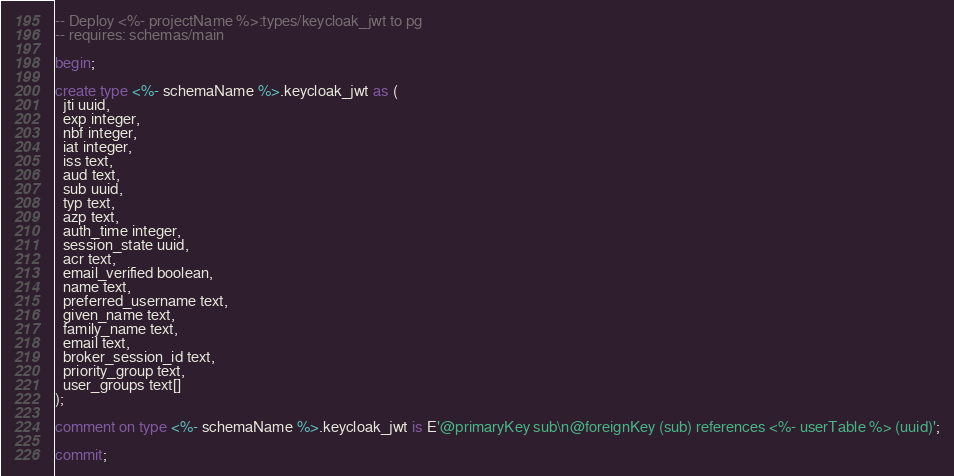Convert code to text. <code><loc_0><loc_0><loc_500><loc_500><_SQL_>-- Deploy <%- projectName %>:types/keycloak_jwt to pg
-- requires: schemas/main

begin;

create type <%- schemaName %>.keycloak_jwt as (
  jti uuid,
  exp integer,
  nbf integer,
  iat integer,
  iss text,
  aud text,
  sub uuid,
  typ text,
  azp text,
  auth_time integer,
  session_state uuid,
  acr text,
  email_verified boolean,
  name text,
  preferred_username text,
  given_name text,
  family_name text,
  email text,
  broker_session_id text,
  priority_group text,
  user_groups text[]
);

comment on type <%- schemaName %>.keycloak_jwt is E'@primaryKey sub\n@foreignKey (sub) references <%- userTable %> (uuid)';

commit;
</code> 